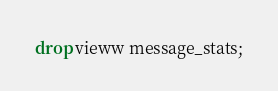<code> <loc_0><loc_0><loc_500><loc_500><_SQL_>drop vieww message_stats;</code> 